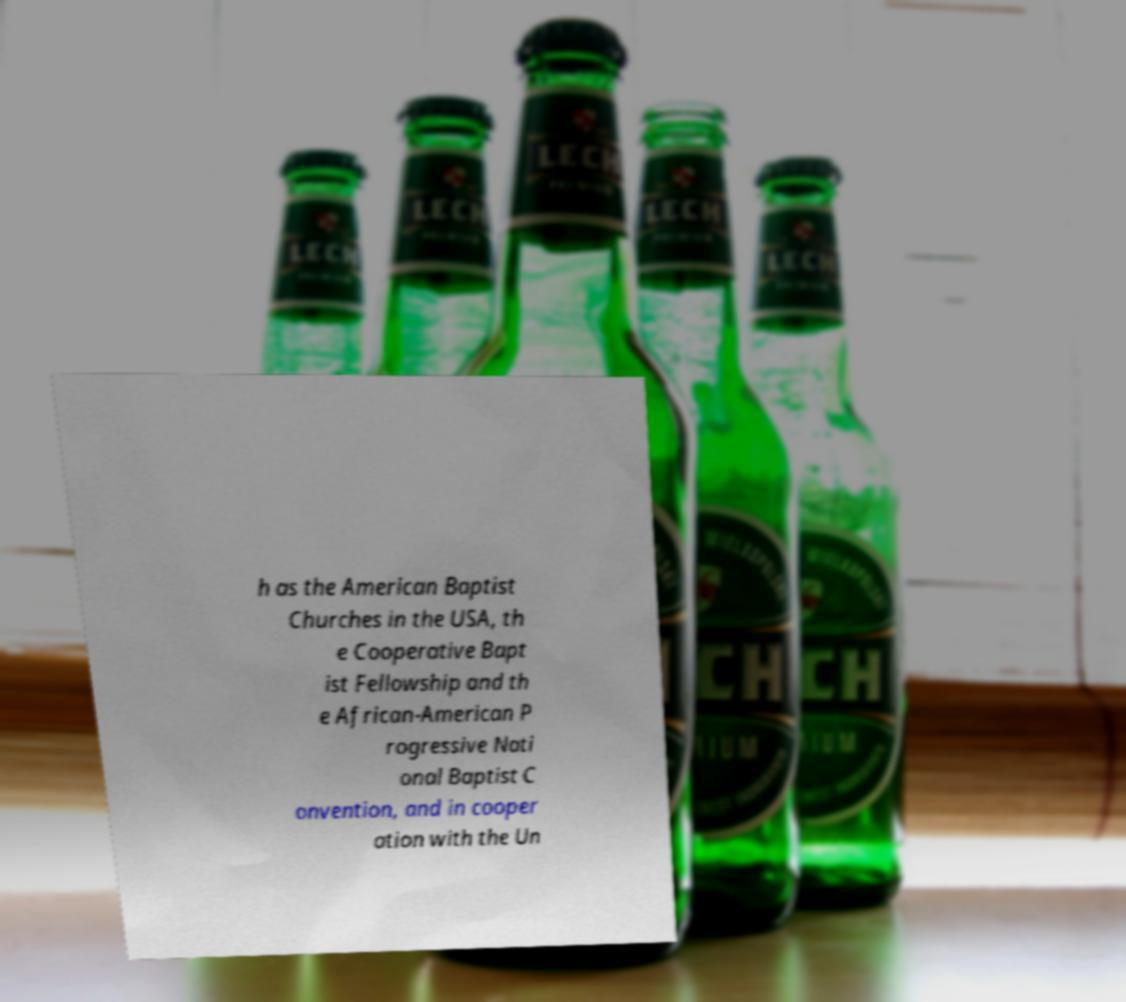Could you extract and type out the text from this image? h as the American Baptist Churches in the USA, th e Cooperative Bapt ist Fellowship and th e African-American P rogressive Nati onal Baptist C onvention, and in cooper ation with the Un 